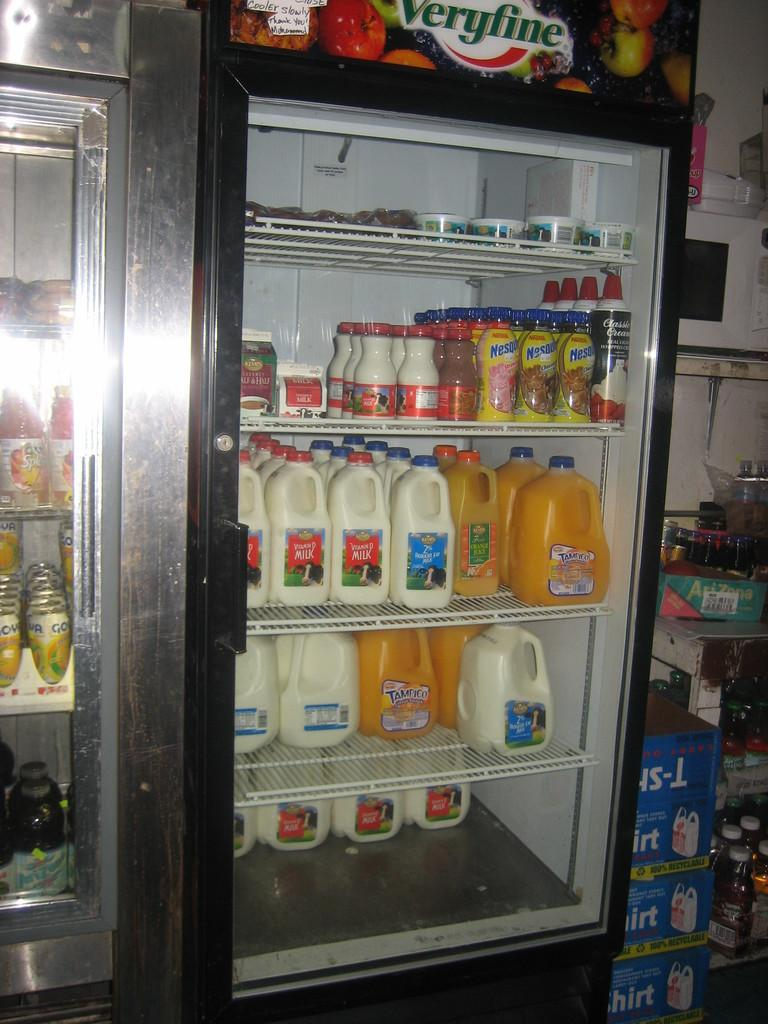<image>
Relay a brief, clear account of the picture shown. A fridge with beverages in it including Kemp's 2 percent milk. 